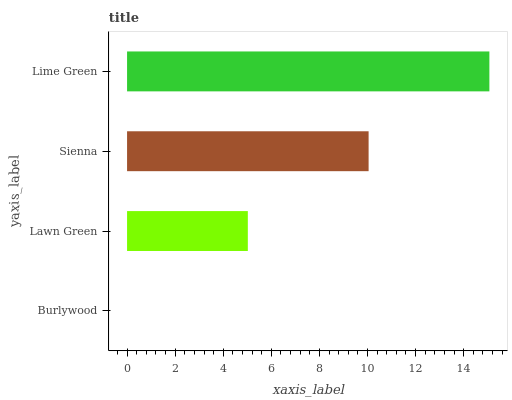Is Burlywood the minimum?
Answer yes or no. Yes. Is Lime Green the maximum?
Answer yes or no. Yes. Is Lawn Green the minimum?
Answer yes or no. No. Is Lawn Green the maximum?
Answer yes or no. No. Is Lawn Green greater than Burlywood?
Answer yes or no. Yes. Is Burlywood less than Lawn Green?
Answer yes or no. Yes. Is Burlywood greater than Lawn Green?
Answer yes or no. No. Is Lawn Green less than Burlywood?
Answer yes or no. No. Is Sienna the high median?
Answer yes or no. Yes. Is Lawn Green the low median?
Answer yes or no. Yes. Is Burlywood the high median?
Answer yes or no. No. Is Burlywood the low median?
Answer yes or no. No. 